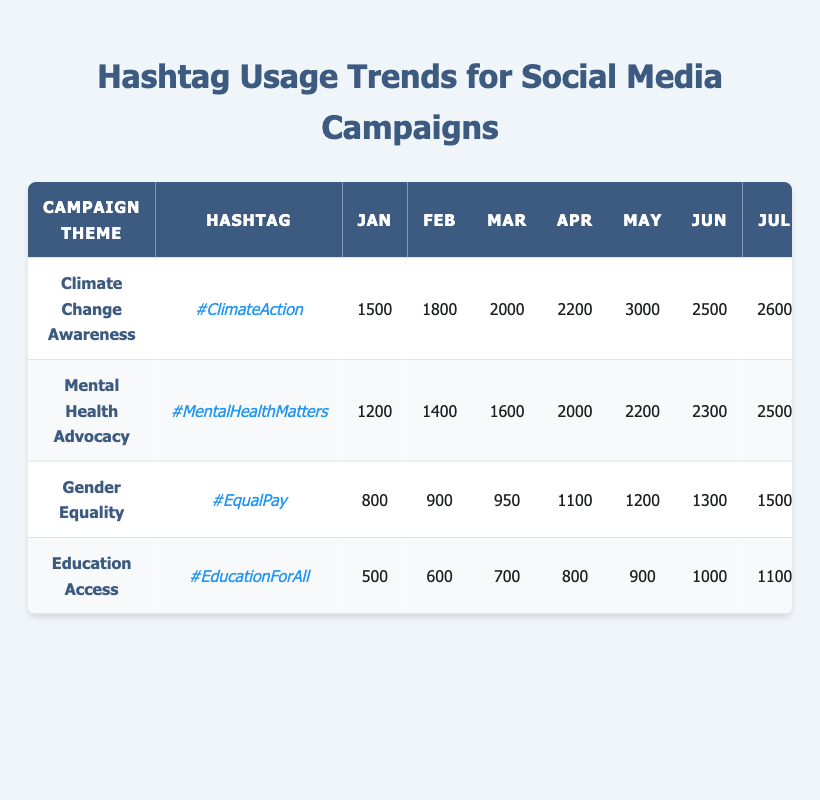What is the hashtag for Climate Change Awareness? The second column of the table lists the hashtags corresponding to their campaign themes. For Climate Change Awareness, the hashtag is found directly next to the campaign theme.
Answer: #ClimateAction In which month did the hashtag #MentalHealthMatters have the highest usage? By examining the monthly usage for the hashtag #MentalHealthMatters, we can see that the highest number occurs in December, which is the last month of the year.
Answer: December What was the total monthly usage of #EqualPay from January to March? To find the total usage, sum the monthly values from January (800), February (900), and March (950). The calculation is 800 + 900 + 950 = 2650.
Answer: 2650 Did #EducationForAll have a higher usage in October compared to February? Looking at the values for #EducationForAll, October shows a usage of 1700, while February shows 600. Since 1700 is greater than 600, the answer is yes.
Answer: Yes What is the average monthly usage of the hashtag #ClimateAction for the months of July to December? First, we sum the monthly usage from July (2600) to December (4500): 2600 + 2700 + 3200 + 3500 + 4000 + 4500 = 22500. Then divide by the number of months, which is 6. The average is 22500 / 6 = 3750.
Answer: 3750 How much more usage did #MentalHealthMatters have in November compared to #EqualPay in the same month? For November, #MentalHealthMatters had a usage of 3600 and #EqualPay had a usage of 2500. The difference is 3600 - 2500 = 1100.
Answer: 1100 Which campaign theme had the lowest maximum usage over the year? To determine this, we compare the maximum monthly usage for each theme. The maximum for #ClimateAction is 4500, #MentalHealthMatters is 4100, #EqualPay is 2800, and #EducationForAll is 2100. The lowest maximum is 2100 associated with the theme Education Access.
Answer: Education Access What was the growth rate of usage for #ClimateAction from January to May? The usage in January is 1500 and in May it is 3000. To find the growth rate, subtract the January value from May (3000 - 1500 = 1500), then divide by the January value (1500 / 1500 = 1), and multiply by 100 for percentage: 1 * 100 = 100%.
Answer: 100% Which hashtag had an increase in usage every month throughout the year? Observing the usage data, #ClimateAction and #MentalHealthMatters show an increase every month, while other hashtags have fluctuations. Upon careful inspection, both have consistent growth each month.
Answer: #ClimateAction and #MentalHealthMatters 